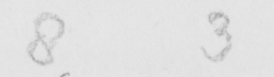Transcribe the text shown in this historical manuscript line. 8 3 